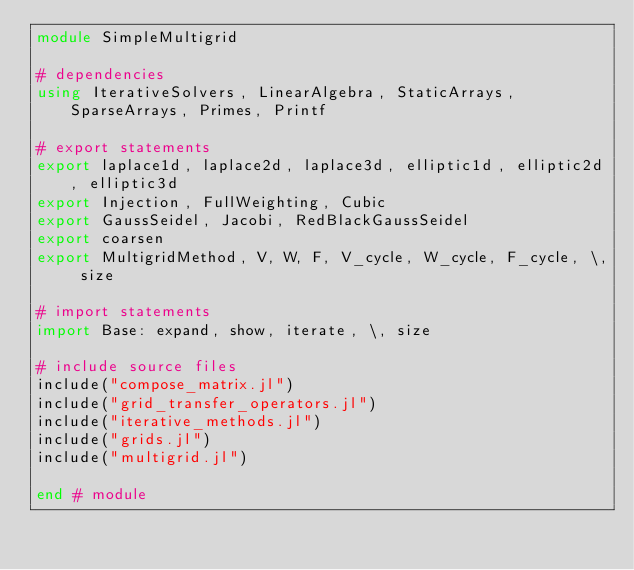<code> <loc_0><loc_0><loc_500><loc_500><_Julia_>module SimpleMultigrid

# dependencies
using IterativeSolvers, LinearAlgebra, StaticArrays, SparseArrays, Primes, Printf

# export statements
export laplace1d, laplace2d, laplace3d, elliptic1d, elliptic2d, elliptic3d
export Injection, FullWeighting, Cubic
export GaussSeidel, Jacobi, RedBlackGaussSeidel
export coarsen
export MultigridMethod, V, W, F, V_cycle, W_cycle, F_cycle, \, size

# import statements
import Base: expand, show, iterate, \, size

# include source files
include("compose_matrix.jl")
include("grid_transfer_operators.jl")
include("iterative_methods.jl")
include("grids.jl")
include("multigrid.jl")

end # module
</code> 